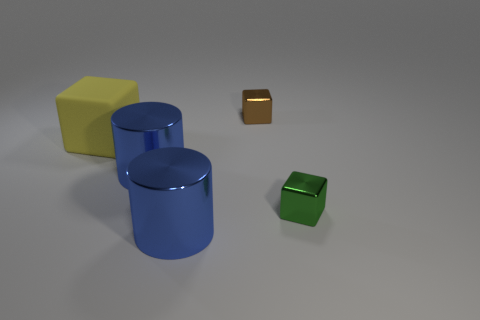Subtract all metal cubes. How many cubes are left? 1 Add 4 tiny green shiny things. How many objects exist? 9 Subtract all cylinders. How many objects are left? 3 Add 1 blue things. How many blue things exist? 3 Subtract 0 purple balls. How many objects are left? 5 Subtract all cyan cubes. Subtract all gray cylinders. How many cubes are left? 3 Subtract all blue balls. Subtract all big metallic objects. How many objects are left? 3 Add 4 small green cubes. How many small green cubes are left? 5 